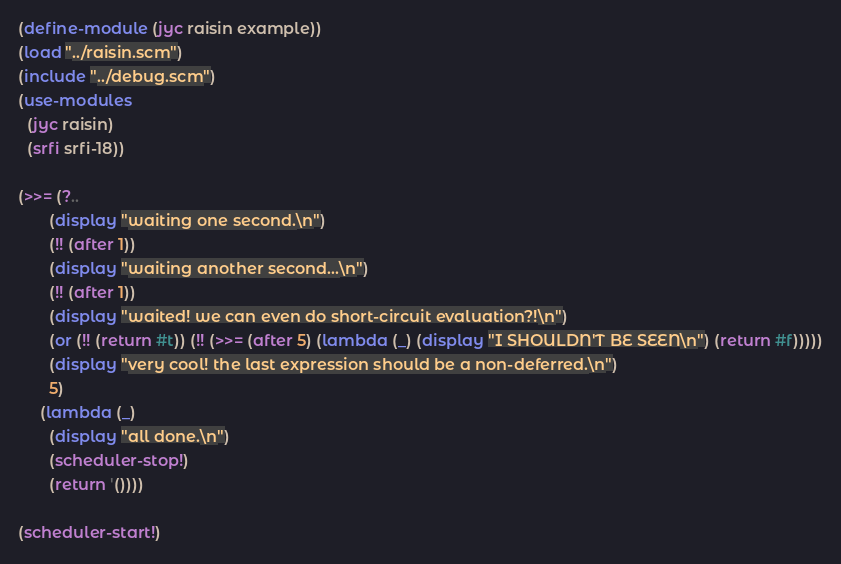<code> <loc_0><loc_0><loc_500><loc_500><_Scheme_>(define-module (jyc raisin example))
(load "../raisin.scm")
(include "../debug.scm")
(use-modules
  (jyc raisin)
  (srfi srfi-18))

(>>= (?..
       (display "waiting one second.\n")
       (!! (after 1))
       (display "waiting another second...\n")
       (!! (after 1))
       (display "waited! we can even do short-circuit evaluation?!\n")
       (or (!! (return #t)) (!! (>>= (after 5) (lambda (_) (display "I SHOULDN'T BE SEEN\n") (return #f)))))
       (display "very cool! the last expression should be a non-deferred.\n")
       5)
     (lambda (_)
       (display "all done.\n")
       (scheduler-stop!)
       (return '())))

(scheduler-start!)
</code> 